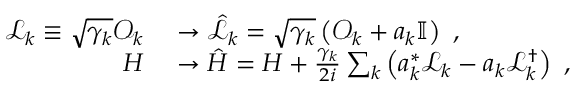<formula> <loc_0><loc_0><loc_500><loc_500>\begin{array} { r l } { \mathcal { L } _ { k } \equiv \sqrt { \gamma _ { k } } \mathcal { O } _ { k } } & \rightarrow \hat { \mathcal { L } } _ { k } = \sqrt { \gamma _ { k } } \left ( \mathcal { O } _ { k } + a _ { k } \mathbb { I } \right ) \, , } \\ { H } & \rightarrow \hat { H } = H + \frac { \gamma _ { k } } { 2 i } \sum _ { k } \left ( a _ { k } ^ { * } \mathcal { L } _ { k } - a _ { k } \mathcal { L } _ { k } ^ { \dagger } \right ) \, , } \end{array}</formula> 